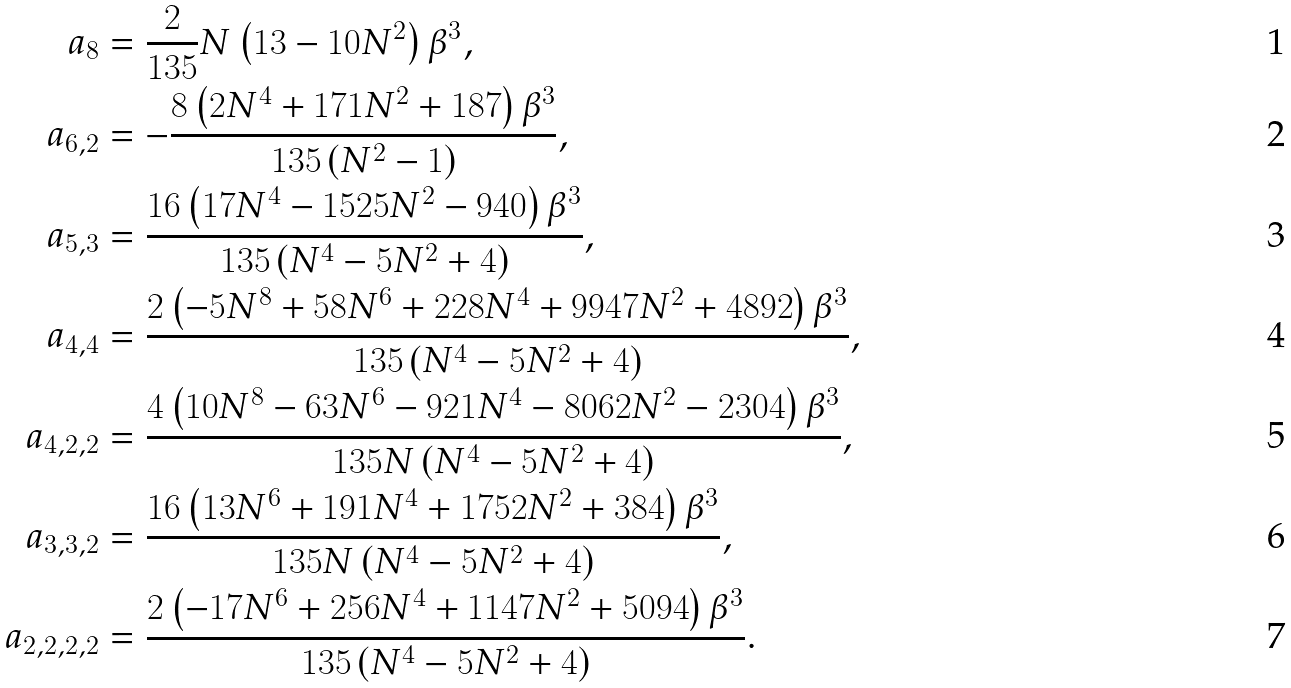<formula> <loc_0><loc_0><loc_500><loc_500>a _ { 8 } & = \frac { 2 } { 1 3 5 } N \left ( 1 3 - 1 0 N ^ { 2 } \right ) \beta ^ { 3 } , \\ a _ { 6 , 2 } & = - \frac { 8 \left ( 2 N ^ { 4 } + 1 7 1 N ^ { 2 } + 1 8 7 \right ) \beta ^ { 3 } } { 1 3 5 \left ( N ^ { 2 } - 1 \right ) } , \\ a _ { 5 , 3 } & = \frac { 1 6 \left ( 1 7 N ^ { 4 } - 1 5 2 5 N ^ { 2 } - 9 4 0 \right ) \beta ^ { 3 } } { 1 3 5 \left ( N ^ { 4 } - 5 N ^ { 2 } + 4 \right ) } , \\ a _ { 4 , 4 } & = \frac { 2 \left ( - 5 N ^ { 8 } + 5 8 N ^ { 6 } + 2 2 8 N ^ { 4 } + 9 9 4 7 N ^ { 2 } + 4 8 9 2 \right ) \beta ^ { 3 } } { 1 3 5 \left ( N ^ { 4 } - 5 N ^ { 2 } + 4 \right ) } , \\ a _ { 4 , 2 , 2 } & = \frac { 4 \left ( 1 0 N ^ { 8 } - 6 3 N ^ { 6 } - 9 2 1 N ^ { 4 } - 8 0 6 2 N ^ { 2 } - 2 3 0 4 \right ) \beta ^ { 3 } } { 1 3 5 N \left ( N ^ { 4 } - 5 N ^ { 2 } + 4 \right ) } , \\ a _ { 3 , 3 , 2 } & = \frac { 1 6 \left ( 1 3 N ^ { 6 } + 1 9 1 N ^ { 4 } + 1 7 5 2 N ^ { 2 } + 3 8 4 \right ) \beta ^ { 3 } } { 1 3 5 N \left ( N ^ { 4 } - 5 N ^ { 2 } + 4 \right ) } , \\ a _ { 2 , 2 , 2 , 2 } & = \frac { 2 \left ( - 1 7 N ^ { 6 } + 2 5 6 N ^ { 4 } + 1 1 4 7 N ^ { 2 } + 5 0 9 4 \right ) \beta ^ { 3 } } { 1 3 5 \left ( N ^ { 4 } - 5 N ^ { 2 } + 4 \right ) } .</formula> 